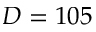<formula> <loc_0><loc_0><loc_500><loc_500>D = 1 0 5</formula> 